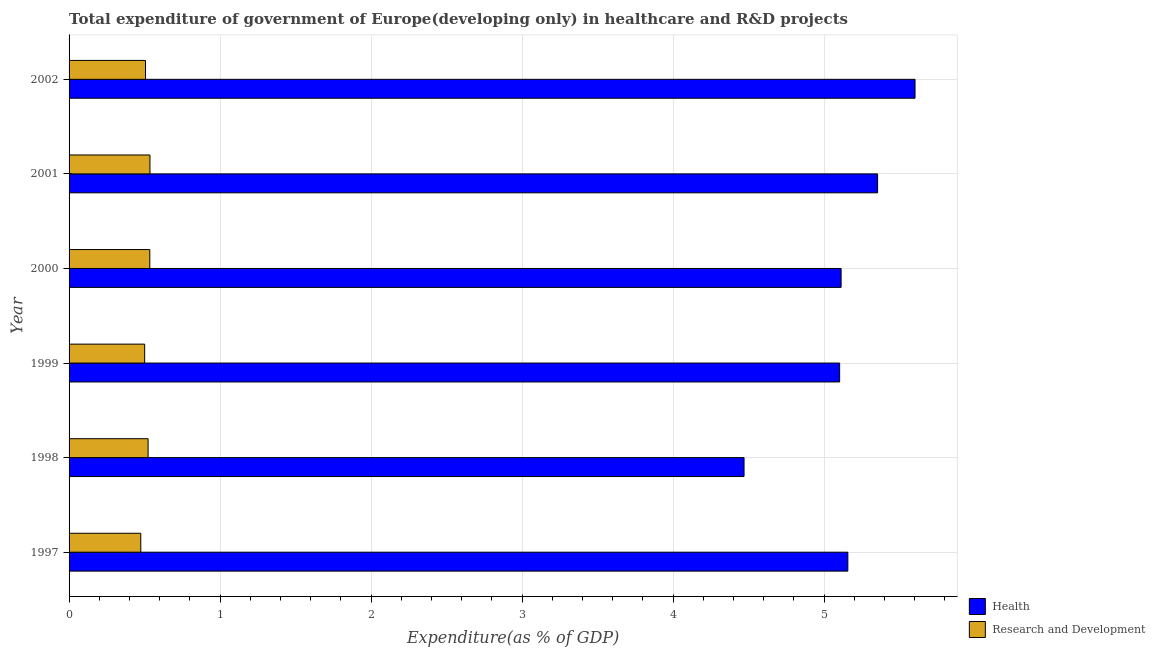How many groups of bars are there?
Make the answer very short. 6. Are the number of bars on each tick of the Y-axis equal?
Offer a terse response. Yes. How many bars are there on the 3rd tick from the bottom?
Provide a succinct answer. 2. In how many cases, is the number of bars for a given year not equal to the number of legend labels?
Offer a terse response. 0. What is the expenditure in healthcare in 2001?
Your response must be concise. 5.35. Across all years, what is the maximum expenditure in r&d?
Your answer should be very brief. 0.54. Across all years, what is the minimum expenditure in r&d?
Ensure brevity in your answer.  0.47. What is the total expenditure in r&d in the graph?
Provide a succinct answer. 3.08. What is the difference between the expenditure in healthcare in 1999 and that in 2002?
Ensure brevity in your answer.  -0.5. What is the difference between the expenditure in r&d in 1997 and the expenditure in healthcare in 1998?
Your response must be concise. -3.99. What is the average expenditure in r&d per year?
Your response must be concise. 0.51. In the year 2001, what is the difference between the expenditure in healthcare and expenditure in r&d?
Your answer should be very brief. 4.82. What is the ratio of the expenditure in healthcare in 2001 to that in 2002?
Give a very brief answer. 0.96. Is the difference between the expenditure in healthcare in 1997 and 2002 greater than the difference between the expenditure in r&d in 1997 and 2002?
Your response must be concise. No. What is the difference between the highest and the second highest expenditure in r&d?
Your answer should be compact. 0. What is the difference between the highest and the lowest expenditure in healthcare?
Your answer should be very brief. 1.13. What does the 2nd bar from the top in 1998 represents?
Your answer should be compact. Health. What does the 2nd bar from the bottom in 2000 represents?
Offer a terse response. Research and Development. How many bars are there?
Provide a succinct answer. 12. How many years are there in the graph?
Offer a very short reply. 6. What is the difference between two consecutive major ticks on the X-axis?
Your response must be concise. 1. Does the graph contain grids?
Your answer should be compact. Yes. Where does the legend appear in the graph?
Give a very brief answer. Bottom right. How many legend labels are there?
Your answer should be very brief. 2. How are the legend labels stacked?
Your response must be concise. Vertical. What is the title of the graph?
Keep it short and to the point. Total expenditure of government of Europe(developing only) in healthcare and R&D projects. Does "Overweight" appear as one of the legend labels in the graph?
Your response must be concise. No. What is the label or title of the X-axis?
Keep it short and to the point. Expenditure(as % of GDP). What is the label or title of the Y-axis?
Offer a very short reply. Year. What is the Expenditure(as % of GDP) in Health in 1997?
Provide a succinct answer. 5.16. What is the Expenditure(as % of GDP) in Research and Development in 1997?
Keep it short and to the point. 0.47. What is the Expenditure(as % of GDP) of Health in 1998?
Keep it short and to the point. 4.47. What is the Expenditure(as % of GDP) in Research and Development in 1998?
Make the answer very short. 0.52. What is the Expenditure(as % of GDP) in Health in 1999?
Provide a succinct answer. 5.1. What is the Expenditure(as % of GDP) in Research and Development in 1999?
Give a very brief answer. 0.5. What is the Expenditure(as % of GDP) in Health in 2000?
Your answer should be very brief. 5.11. What is the Expenditure(as % of GDP) in Research and Development in 2000?
Your answer should be compact. 0.53. What is the Expenditure(as % of GDP) of Health in 2001?
Your response must be concise. 5.35. What is the Expenditure(as % of GDP) of Research and Development in 2001?
Make the answer very short. 0.54. What is the Expenditure(as % of GDP) of Health in 2002?
Provide a short and direct response. 5.6. What is the Expenditure(as % of GDP) of Research and Development in 2002?
Offer a very short reply. 0.51. Across all years, what is the maximum Expenditure(as % of GDP) in Health?
Provide a succinct answer. 5.6. Across all years, what is the maximum Expenditure(as % of GDP) in Research and Development?
Your answer should be compact. 0.54. Across all years, what is the minimum Expenditure(as % of GDP) in Health?
Offer a very short reply. 4.47. Across all years, what is the minimum Expenditure(as % of GDP) of Research and Development?
Ensure brevity in your answer.  0.47. What is the total Expenditure(as % of GDP) in Health in the graph?
Offer a very short reply. 30.8. What is the total Expenditure(as % of GDP) of Research and Development in the graph?
Provide a short and direct response. 3.08. What is the difference between the Expenditure(as % of GDP) in Health in 1997 and that in 1998?
Give a very brief answer. 0.69. What is the difference between the Expenditure(as % of GDP) of Research and Development in 1997 and that in 1998?
Your answer should be very brief. -0.05. What is the difference between the Expenditure(as % of GDP) in Health in 1997 and that in 1999?
Make the answer very short. 0.05. What is the difference between the Expenditure(as % of GDP) of Research and Development in 1997 and that in 1999?
Your answer should be very brief. -0.03. What is the difference between the Expenditure(as % of GDP) in Health in 1997 and that in 2000?
Offer a terse response. 0.04. What is the difference between the Expenditure(as % of GDP) of Research and Development in 1997 and that in 2000?
Offer a terse response. -0.06. What is the difference between the Expenditure(as % of GDP) of Health in 1997 and that in 2001?
Offer a very short reply. -0.2. What is the difference between the Expenditure(as % of GDP) of Research and Development in 1997 and that in 2001?
Offer a terse response. -0.06. What is the difference between the Expenditure(as % of GDP) in Health in 1997 and that in 2002?
Ensure brevity in your answer.  -0.44. What is the difference between the Expenditure(as % of GDP) of Research and Development in 1997 and that in 2002?
Give a very brief answer. -0.03. What is the difference between the Expenditure(as % of GDP) of Health in 1998 and that in 1999?
Your answer should be compact. -0.63. What is the difference between the Expenditure(as % of GDP) in Research and Development in 1998 and that in 1999?
Give a very brief answer. 0.02. What is the difference between the Expenditure(as % of GDP) of Health in 1998 and that in 2000?
Provide a succinct answer. -0.64. What is the difference between the Expenditure(as % of GDP) of Research and Development in 1998 and that in 2000?
Give a very brief answer. -0.01. What is the difference between the Expenditure(as % of GDP) of Health in 1998 and that in 2001?
Keep it short and to the point. -0.88. What is the difference between the Expenditure(as % of GDP) in Research and Development in 1998 and that in 2001?
Ensure brevity in your answer.  -0.01. What is the difference between the Expenditure(as % of GDP) of Health in 1998 and that in 2002?
Give a very brief answer. -1.13. What is the difference between the Expenditure(as % of GDP) in Research and Development in 1998 and that in 2002?
Your answer should be compact. 0.02. What is the difference between the Expenditure(as % of GDP) of Health in 1999 and that in 2000?
Ensure brevity in your answer.  -0.01. What is the difference between the Expenditure(as % of GDP) of Research and Development in 1999 and that in 2000?
Ensure brevity in your answer.  -0.03. What is the difference between the Expenditure(as % of GDP) of Health in 1999 and that in 2001?
Your response must be concise. -0.25. What is the difference between the Expenditure(as % of GDP) in Research and Development in 1999 and that in 2001?
Give a very brief answer. -0.04. What is the difference between the Expenditure(as % of GDP) of Health in 1999 and that in 2002?
Provide a succinct answer. -0.5. What is the difference between the Expenditure(as % of GDP) in Research and Development in 1999 and that in 2002?
Offer a very short reply. -0.01. What is the difference between the Expenditure(as % of GDP) in Health in 2000 and that in 2001?
Give a very brief answer. -0.24. What is the difference between the Expenditure(as % of GDP) of Research and Development in 2000 and that in 2001?
Make the answer very short. -0. What is the difference between the Expenditure(as % of GDP) in Health in 2000 and that in 2002?
Keep it short and to the point. -0.49. What is the difference between the Expenditure(as % of GDP) in Research and Development in 2000 and that in 2002?
Give a very brief answer. 0.03. What is the difference between the Expenditure(as % of GDP) in Health in 2001 and that in 2002?
Ensure brevity in your answer.  -0.25. What is the difference between the Expenditure(as % of GDP) of Research and Development in 2001 and that in 2002?
Give a very brief answer. 0.03. What is the difference between the Expenditure(as % of GDP) of Health in 1997 and the Expenditure(as % of GDP) of Research and Development in 1998?
Make the answer very short. 4.63. What is the difference between the Expenditure(as % of GDP) of Health in 1997 and the Expenditure(as % of GDP) of Research and Development in 1999?
Give a very brief answer. 4.66. What is the difference between the Expenditure(as % of GDP) in Health in 1997 and the Expenditure(as % of GDP) in Research and Development in 2000?
Your response must be concise. 4.62. What is the difference between the Expenditure(as % of GDP) of Health in 1997 and the Expenditure(as % of GDP) of Research and Development in 2001?
Your answer should be very brief. 4.62. What is the difference between the Expenditure(as % of GDP) in Health in 1997 and the Expenditure(as % of GDP) in Research and Development in 2002?
Your response must be concise. 4.65. What is the difference between the Expenditure(as % of GDP) of Health in 1998 and the Expenditure(as % of GDP) of Research and Development in 1999?
Give a very brief answer. 3.97. What is the difference between the Expenditure(as % of GDP) of Health in 1998 and the Expenditure(as % of GDP) of Research and Development in 2000?
Give a very brief answer. 3.94. What is the difference between the Expenditure(as % of GDP) of Health in 1998 and the Expenditure(as % of GDP) of Research and Development in 2001?
Provide a short and direct response. 3.93. What is the difference between the Expenditure(as % of GDP) of Health in 1998 and the Expenditure(as % of GDP) of Research and Development in 2002?
Keep it short and to the point. 3.96. What is the difference between the Expenditure(as % of GDP) of Health in 1999 and the Expenditure(as % of GDP) of Research and Development in 2000?
Provide a succinct answer. 4.57. What is the difference between the Expenditure(as % of GDP) of Health in 1999 and the Expenditure(as % of GDP) of Research and Development in 2001?
Your answer should be very brief. 4.57. What is the difference between the Expenditure(as % of GDP) in Health in 1999 and the Expenditure(as % of GDP) in Research and Development in 2002?
Provide a succinct answer. 4.6. What is the difference between the Expenditure(as % of GDP) in Health in 2000 and the Expenditure(as % of GDP) in Research and Development in 2001?
Your response must be concise. 4.58. What is the difference between the Expenditure(as % of GDP) in Health in 2000 and the Expenditure(as % of GDP) in Research and Development in 2002?
Provide a succinct answer. 4.61. What is the difference between the Expenditure(as % of GDP) in Health in 2001 and the Expenditure(as % of GDP) in Research and Development in 2002?
Provide a short and direct response. 4.85. What is the average Expenditure(as % of GDP) in Health per year?
Provide a succinct answer. 5.13. What is the average Expenditure(as % of GDP) of Research and Development per year?
Provide a succinct answer. 0.51. In the year 1997, what is the difference between the Expenditure(as % of GDP) of Health and Expenditure(as % of GDP) of Research and Development?
Your answer should be compact. 4.68. In the year 1998, what is the difference between the Expenditure(as % of GDP) in Health and Expenditure(as % of GDP) in Research and Development?
Your response must be concise. 3.95. In the year 1999, what is the difference between the Expenditure(as % of GDP) in Health and Expenditure(as % of GDP) in Research and Development?
Offer a very short reply. 4.6. In the year 2000, what is the difference between the Expenditure(as % of GDP) in Health and Expenditure(as % of GDP) in Research and Development?
Give a very brief answer. 4.58. In the year 2001, what is the difference between the Expenditure(as % of GDP) of Health and Expenditure(as % of GDP) of Research and Development?
Keep it short and to the point. 4.82. In the year 2002, what is the difference between the Expenditure(as % of GDP) of Health and Expenditure(as % of GDP) of Research and Development?
Your answer should be very brief. 5.1. What is the ratio of the Expenditure(as % of GDP) of Health in 1997 to that in 1998?
Your answer should be compact. 1.15. What is the ratio of the Expenditure(as % of GDP) of Research and Development in 1997 to that in 1998?
Offer a terse response. 0.91. What is the ratio of the Expenditure(as % of GDP) of Health in 1997 to that in 1999?
Ensure brevity in your answer.  1.01. What is the ratio of the Expenditure(as % of GDP) of Research and Development in 1997 to that in 1999?
Your response must be concise. 0.95. What is the ratio of the Expenditure(as % of GDP) in Health in 1997 to that in 2000?
Your answer should be compact. 1.01. What is the ratio of the Expenditure(as % of GDP) of Research and Development in 1997 to that in 2000?
Your answer should be compact. 0.89. What is the ratio of the Expenditure(as % of GDP) in Health in 1997 to that in 2001?
Your response must be concise. 0.96. What is the ratio of the Expenditure(as % of GDP) in Research and Development in 1997 to that in 2001?
Give a very brief answer. 0.89. What is the ratio of the Expenditure(as % of GDP) in Health in 1997 to that in 2002?
Offer a terse response. 0.92. What is the ratio of the Expenditure(as % of GDP) of Research and Development in 1997 to that in 2002?
Make the answer very short. 0.94. What is the ratio of the Expenditure(as % of GDP) of Health in 1998 to that in 1999?
Provide a short and direct response. 0.88. What is the ratio of the Expenditure(as % of GDP) in Research and Development in 1998 to that in 1999?
Your answer should be compact. 1.05. What is the ratio of the Expenditure(as % of GDP) of Health in 1998 to that in 2000?
Give a very brief answer. 0.87. What is the ratio of the Expenditure(as % of GDP) in Research and Development in 1998 to that in 2000?
Ensure brevity in your answer.  0.98. What is the ratio of the Expenditure(as % of GDP) in Health in 1998 to that in 2001?
Your response must be concise. 0.83. What is the ratio of the Expenditure(as % of GDP) in Research and Development in 1998 to that in 2001?
Provide a short and direct response. 0.98. What is the ratio of the Expenditure(as % of GDP) of Health in 1998 to that in 2002?
Provide a short and direct response. 0.8. What is the ratio of the Expenditure(as % of GDP) in Research and Development in 1998 to that in 2002?
Make the answer very short. 1.03. What is the ratio of the Expenditure(as % of GDP) of Health in 1999 to that in 2000?
Make the answer very short. 1. What is the ratio of the Expenditure(as % of GDP) of Research and Development in 1999 to that in 2000?
Your answer should be compact. 0.94. What is the ratio of the Expenditure(as % of GDP) in Health in 1999 to that in 2001?
Offer a very short reply. 0.95. What is the ratio of the Expenditure(as % of GDP) in Research and Development in 1999 to that in 2001?
Give a very brief answer. 0.93. What is the ratio of the Expenditure(as % of GDP) in Health in 1999 to that in 2002?
Your response must be concise. 0.91. What is the ratio of the Expenditure(as % of GDP) in Health in 2000 to that in 2001?
Offer a terse response. 0.95. What is the ratio of the Expenditure(as % of GDP) in Health in 2000 to that in 2002?
Keep it short and to the point. 0.91. What is the ratio of the Expenditure(as % of GDP) in Research and Development in 2000 to that in 2002?
Ensure brevity in your answer.  1.06. What is the ratio of the Expenditure(as % of GDP) in Health in 2001 to that in 2002?
Your answer should be compact. 0.96. What is the ratio of the Expenditure(as % of GDP) of Research and Development in 2001 to that in 2002?
Your answer should be compact. 1.06. What is the difference between the highest and the second highest Expenditure(as % of GDP) of Health?
Make the answer very short. 0.25. What is the difference between the highest and the second highest Expenditure(as % of GDP) of Research and Development?
Provide a short and direct response. 0. What is the difference between the highest and the lowest Expenditure(as % of GDP) of Health?
Give a very brief answer. 1.13. What is the difference between the highest and the lowest Expenditure(as % of GDP) of Research and Development?
Your answer should be very brief. 0.06. 